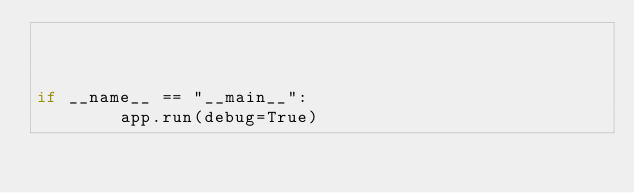<code> <loc_0><loc_0><loc_500><loc_500><_Python_>


if __name__ == "__main__":
        app.run(debug=True)</code> 